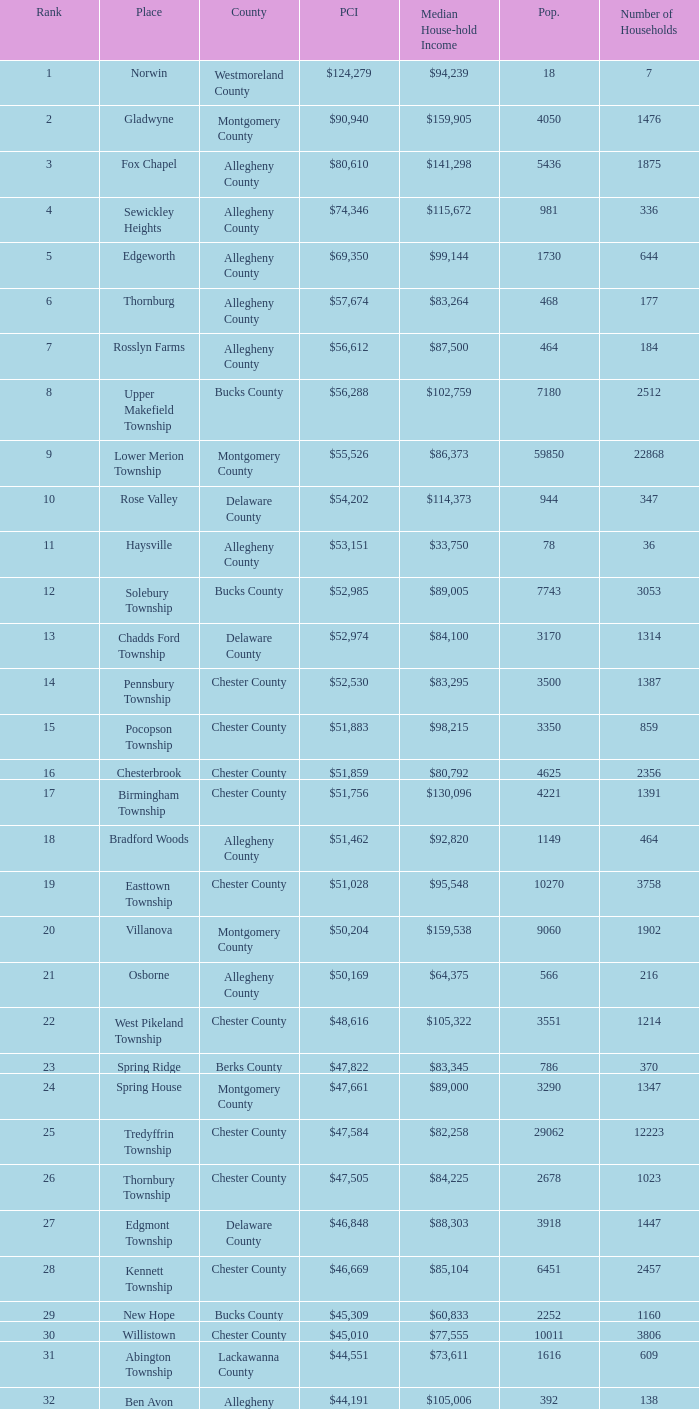Which county has a median household income of  $98,090? Bucks County. 